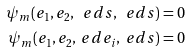<formula> <loc_0><loc_0><loc_500><loc_500>\psi _ { m } ( e _ { 1 } , e _ { 2 } , \ e d s , \ e d s ) & = 0 \\ \psi _ { m } ( e _ { 1 } , e _ { 2 } , \ e d e _ { i } , \ e d s ) & = 0</formula> 